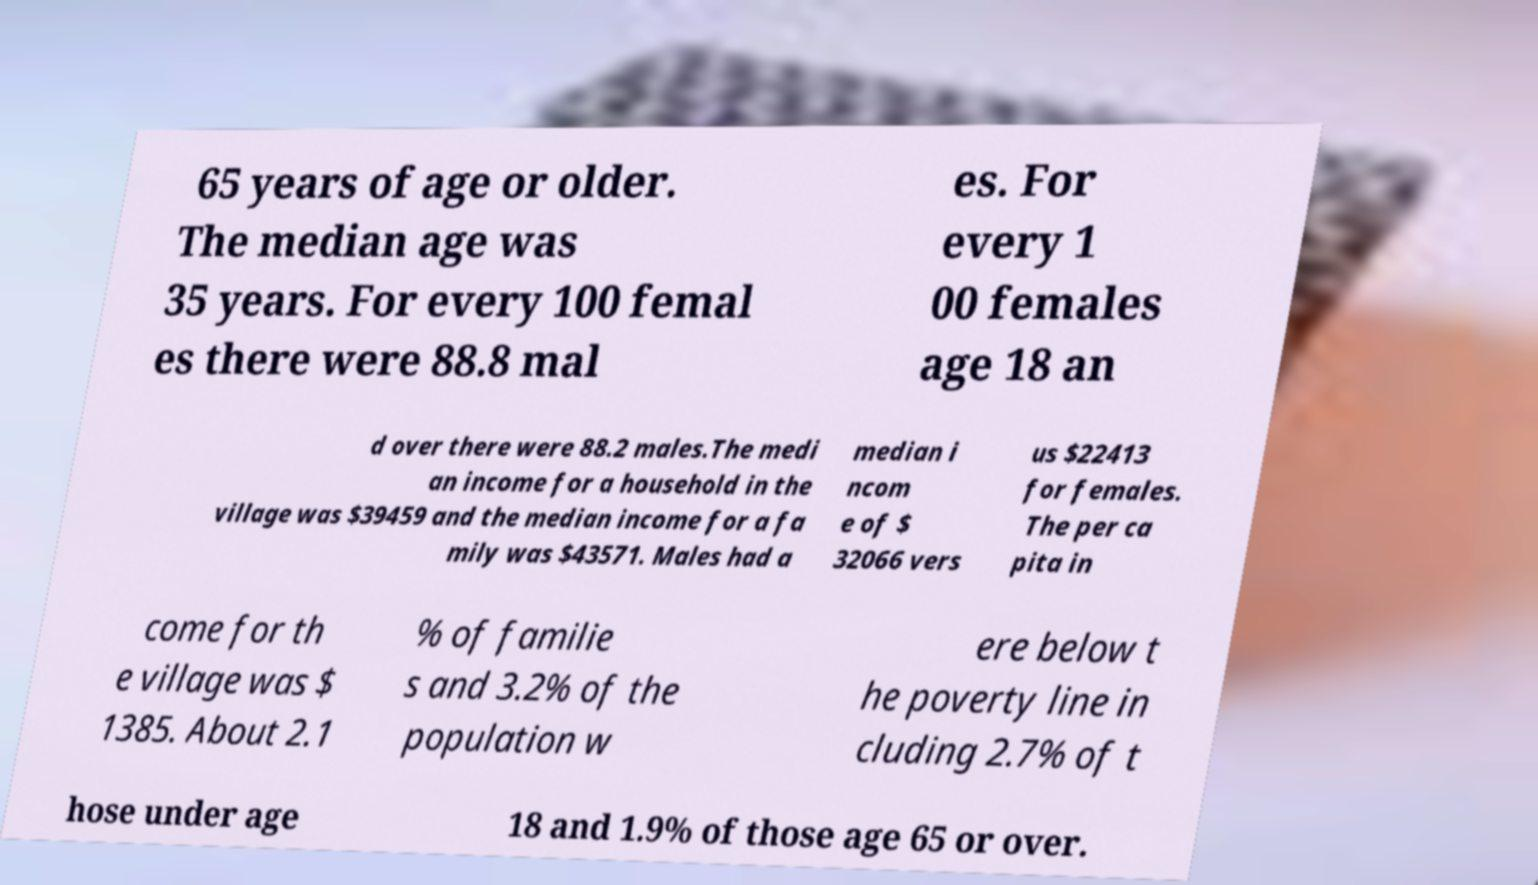For documentation purposes, I need the text within this image transcribed. Could you provide that? 65 years of age or older. The median age was 35 years. For every 100 femal es there were 88.8 mal es. For every 1 00 females age 18 an d over there were 88.2 males.The medi an income for a household in the village was $39459 and the median income for a fa mily was $43571. Males had a median i ncom e of $ 32066 vers us $22413 for females. The per ca pita in come for th e village was $ 1385. About 2.1 % of familie s and 3.2% of the population w ere below t he poverty line in cluding 2.7% of t hose under age 18 and 1.9% of those age 65 or over. 